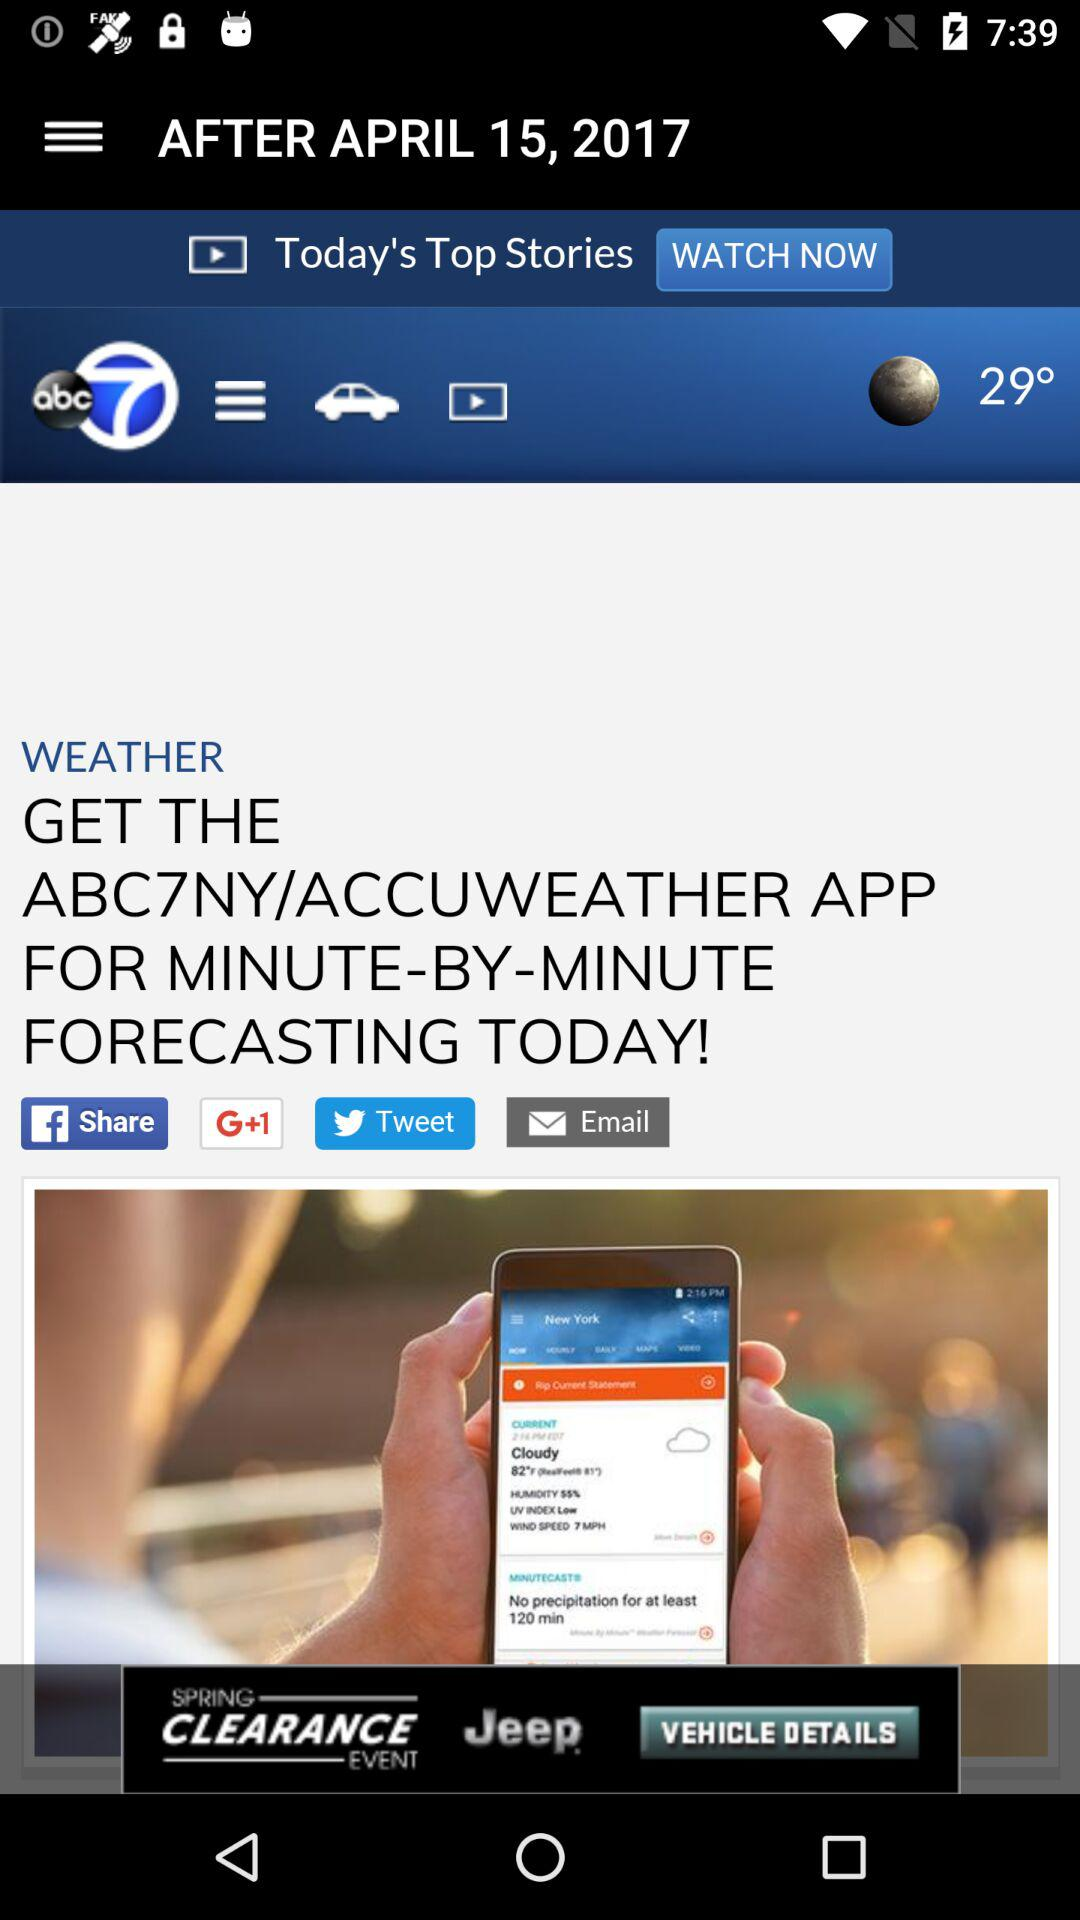What is the mentioned date? The mentioned date is April 15, 2017. 